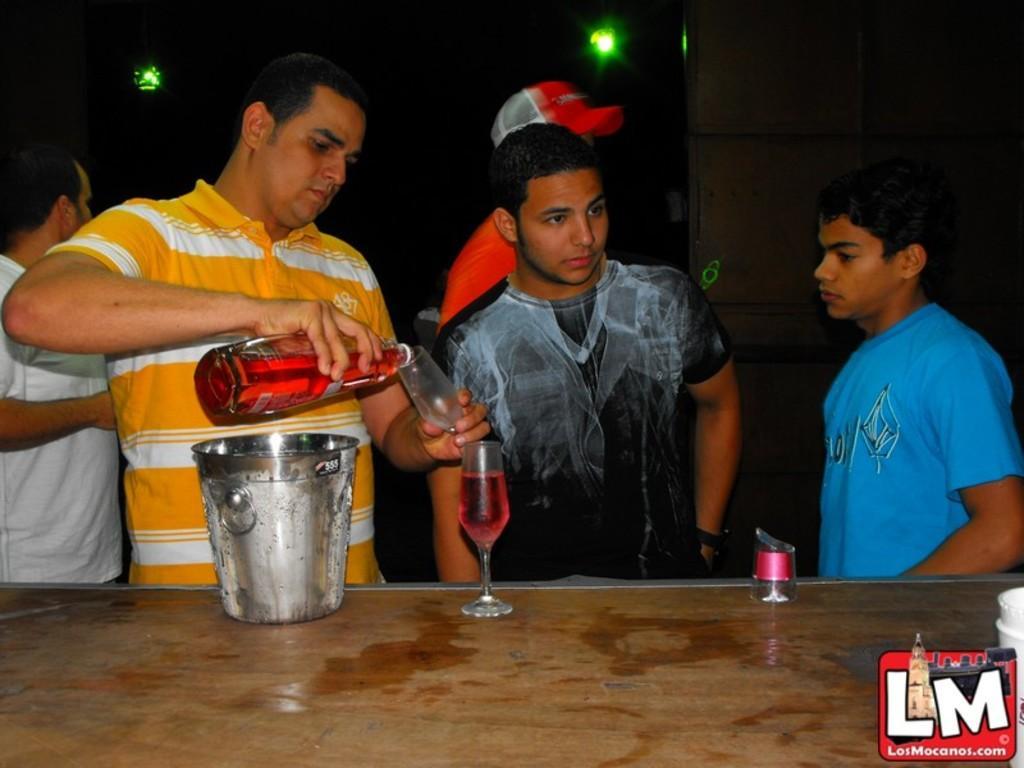How would you summarize this image in a sentence or two? In this image, there are three persons wearing clothes and standing in front of the table. This table contains a glass and bucket. There is a person on the left side of the image holding a bottle and glass with his hands. There is a light at the top of the image. 